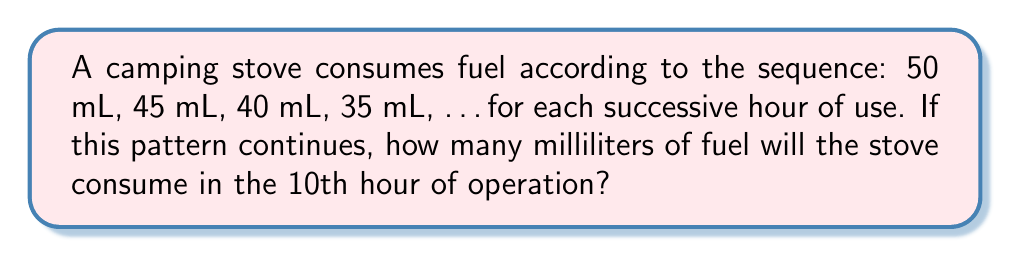Can you answer this question? To solve this problem, let's follow these steps:

1) First, we need to identify the pattern in the sequence:
   50 mL, 45 mL, 40 mL, 35 mL, ...

2) We can see that the fuel consumption decreases by 5 mL each hour:
   50 - 45 = 5
   45 - 40 = 5
   40 - 35 = 5

3) This forms an arithmetic sequence with a common difference of -5 mL.

4) We can represent this sequence using the formula:
   $$a_n = a_1 + (n-1)d$$
   where $a_n$ is the nth term, $a_1$ is the first term, n is the position of the term, and d is the common difference.

5) In this case:
   $a_1 = 50$ (first term)
   $d = -5$ (common difference)
   $n = 10$ (we want the 10th term)

6) Substituting these values into the formula:
   $$a_{10} = 50 + (10-1)(-5)$$
   $$a_{10} = 50 + (9)(-5)$$
   $$a_{10} = 50 - 45$$
   $$a_{10} = 5$$

Therefore, in the 10th hour of operation, the stove will consume 5 mL of fuel.
Answer: 5 mL 